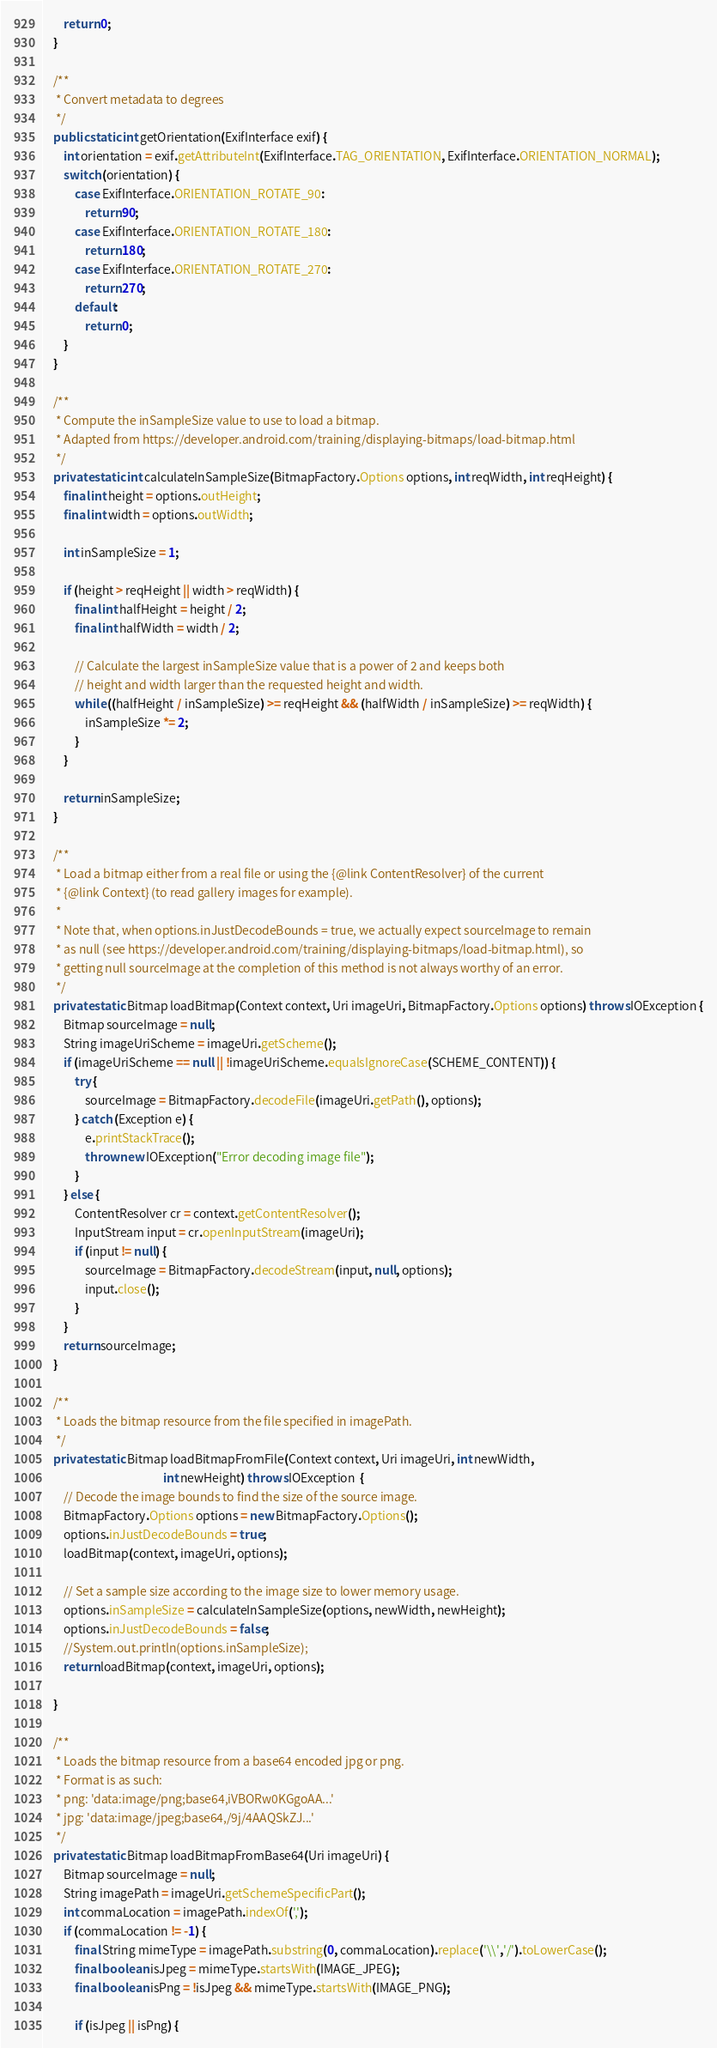Convert code to text. <code><loc_0><loc_0><loc_500><loc_500><_Java_>
        return 0;
    }

    /**
     * Convert metadata to degrees
     */
    public static int getOrientation(ExifInterface exif) {
        int orientation = exif.getAttributeInt(ExifInterface.TAG_ORIENTATION, ExifInterface.ORIENTATION_NORMAL);
        switch (orientation) {
            case ExifInterface.ORIENTATION_ROTATE_90:
                return 90;
            case ExifInterface.ORIENTATION_ROTATE_180:
                return 180;
            case ExifInterface.ORIENTATION_ROTATE_270:
                return 270;
            default:
                return 0;
        }
    }

    /**
     * Compute the inSampleSize value to use to load a bitmap.
     * Adapted from https://developer.android.com/training/displaying-bitmaps/load-bitmap.html
     */
    private static int calculateInSampleSize(BitmapFactory.Options options, int reqWidth, int reqHeight) {
        final int height = options.outHeight;
        final int width = options.outWidth;

        int inSampleSize = 1;

        if (height > reqHeight || width > reqWidth) {
            final int halfHeight = height / 2;
            final int halfWidth = width / 2;

            // Calculate the largest inSampleSize value that is a power of 2 and keeps both
            // height and width larger than the requested height and width.
            while ((halfHeight / inSampleSize) >= reqHeight && (halfWidth / inSampleSize) >= reqWidth) {
                inSampleSize *= 2;
            }
        }

        return inSampleSize;
    }

    /**
     * Load a bitmap either from a real file or using the {@link ContentResolver} of the current
     * {@link Context} (to read gallery images for example).
     *
     * Note that, when options.inJustDecodeBounds = true, we actually expect sourceImage to remain
     * as null (see https://developer.android.com/training/displaying-bitmaps/load-bitmap.html), so
     * getting null sourceImage at the completion of this method is not always worthy of an error.
     */
    private static Bitmap loadBitmap(Context context, Uri imageUri, BitmapFactory.Options options) throws IOException {
        Bitmap sourceImage = null;
        String imageUriScheme = imageUri.getScheme();
        if (imageUriScheme == null || !imageUriScheme.equalsIgnoreCase(SCHEME_CONTENT)) {
            try {
                sourceImage = BitmapFactory.decodeFile(imageUri.getPath(), options);
            } catch (Exception e) {
                e.printStackTrace();
                throw new IOException("Error decoding image file");
            }
        } else {
            ContentResolver cr = context.getContentResolver();
            InputStream input = cr.openInputStream(imageUri);
            if (input != null) {
                sourceImage = BitmapFactory.decodeStream(input, null, options);
                input.close();
            }
        }
        return sourceImage;
    }

    /**
     * Loads the bitmap resource from the file specified in imagePath.
     */
    private static Bitmap loadBitmapFromFile(Context context, Uri imageUri, int newWidth,
                                             int newHeight) throws IOException  {
        // Decode the image bounds to find the size of the source image.
        BitmapFactory.Options options = new BitmapFactory.Options();
        options.inJustDecodeBounds = true;
        loadBitmap(context, imageUri, options);

        // Set a sample size according to the image size to lower memory usage.
        options.inSampleSize = calculateInSampleSize(options, newWidth, newHeight);
        options.inJustDecodeBounds = false;
        //System.out.println(options.inSampleSize);
        return loadBitmap(context, imageUri, options);

    }

    /**
     * Loads the bitmap resource from a base64 encoded jpg or png.
     * Format is as such:
     * png: 'data:image/png;base64,iVBORw0KGgoAA...'
     * jpg: 'data:image/jpeg;base64,/9j/4AAQSkZJ...'
     */
    private static Bitmap loadBitmapFromBase64(Uri imageUri) {
        Bitmap sourceImage = null;
        String imagePath = imageUri.getSchemeSpecificPart();
        int commaLocation = imagePath.indexOf(',');
        if (commaLocation != -1) {
            final String mimeType = imagePath.substring(0, commaLocation).replace('\\','/').toLowerCase();
            final boolean isJpeg = mimeType.startsWith(IMAGE_JPEG);
            final boolean isPng = !isJpeg && mimeType.startsWith(IMAGE_PNG);

            if (isJpeg || isPng) {</code> 